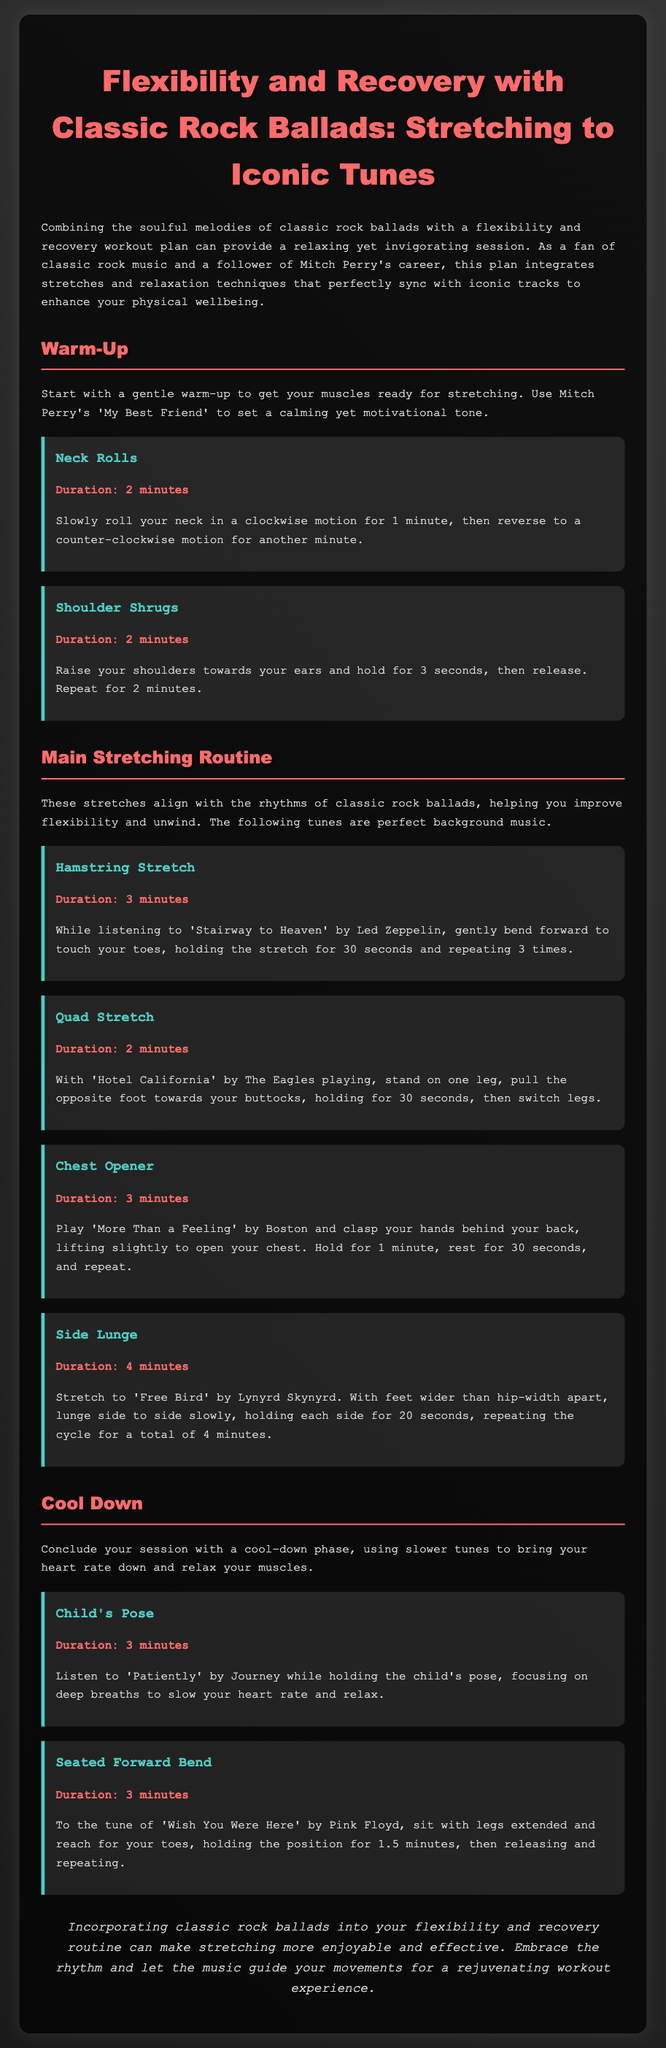What song is suggested for the warm-up? The document mentions using Mitch Perry's 'My Best Friend' for the warm-up.
Answer: My Best Friend How long should you perform neck rolls? The document states to perform neck rolls for 2 minutes.
Answer: 2 minutes What is the duration of the Hamstring Stretch? The Hamstring Stretch is specified to last for 3 minutes in the document.
Answer: 3 minutes Which song accompanies the Side Lunge exercise? 'Free Bird' by Lynyrd Skynyrd is indicated as the song for the Side Lunge.
Answer: Free Bird What stretch follows the Child's Pose? The Seated Forward Bend is described as the stretch following the Child's Pose.
Answer: Seated Forward Bend How many times should you repeat the Hamstring Stretch? The routine suggests repeating the Hamstring Stretch 3 times.
Answer: 3 times What is the main theme of the workout plan? The main theme combines flexibility and recovery workouts with classic rock ballads.
Answer: Flexibility and recovery Which classic rock band has a song featured in the cool-down? 'Wish You Were Here' by Pink Floyd is noted in the cool-down section.
Answer: Pink Floyd 